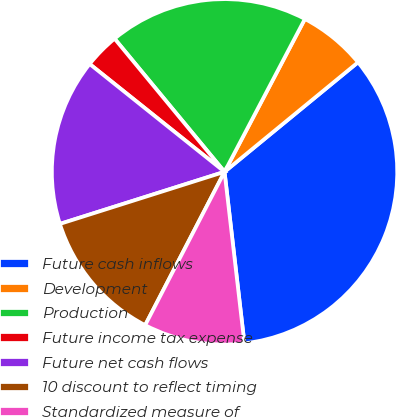Convert chart. <chart><loc_0><loc_0><loc_500><loc_500><pie_chart><fcel>Future cash inflows<fcel>Development<fcel>Production<fcel>Future income tax expense<fcel>Future net cash flows<fcel>10 discount to reflect timing<fcel>Standardized measure of<nl><fcel>34.1%<fcel>6.36%<fcel>18.69%<fcel>3.28%<fcel>15.61%<fcel>12.52%<fcel>9.44%<nl></chart> 